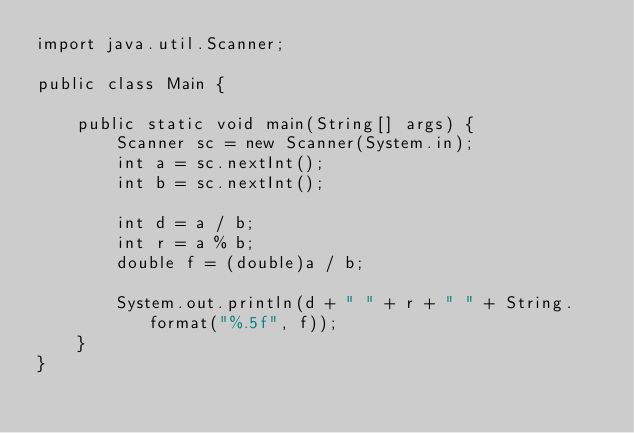<code> <loc_0><loc_0><loc_500><loc_500><_Java_>import java.util.Scanner;
 
public class Main {
 
    public static void main(String[] args) {
        Scanner sc = new Scanner(System.in); 
        int a = sc.nextInt();
        int b = sc.nextInt();
         
        int d = a / b;
        int r = a % b;
        double f = (double)a / b;
 
        System.out.println(d + " " + r + " " + String.format("%.5f", f));
    }
}</code> 